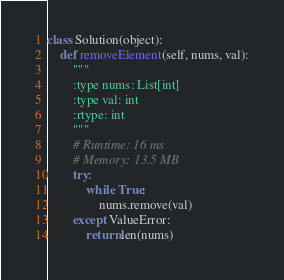<code> <loc_0><loc_0><loc_500><loc_500><_Python_>class Solution(object):
    def removeElement(self, nums, val):
        """
        :type nums: List[int]
        :type val: int
        :rtype: int
        """
        # Runtime: 16 ms
        # Memory: 13.5 MB
        try:
            while True:
                nums.remove(val)
        except ValueError:
            return len(nums)
</code> 